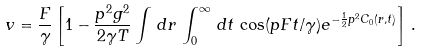Convert formula to latex. <formula><loc_0><loc_0><loc_500><loc_500>v = \frac { F } { \gamma } \left [ 1 - \frac { p ^ { 2 } g ^ { 2 } } { 2 \gamma T } \int \, d { r } \, \int _ { 0 } ^ { \infty } \, d t \, \cos ( p F t / \gamma ) e ^ { - \frac { 1 } { 2 } p ^ { 2 } C _ { 0 } ( { r } , t ) } \right ] \, .</formula> 